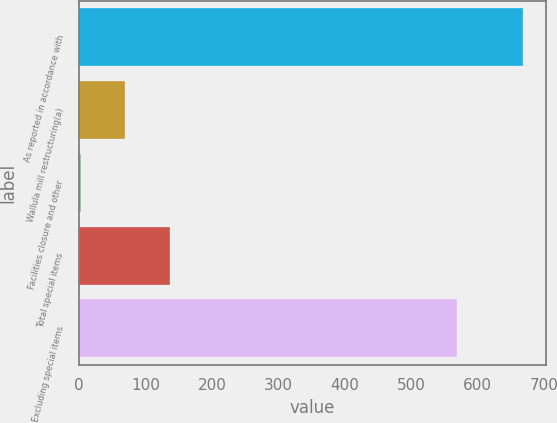Convert chart. <chart><loc_0><loc_0><loc_500><loc_500><bar_chart><fcel>As reported in accordance with<fcel>Wallula mill restructuring(a)<fcel>Facilities closure and other<fcel>Total special items<fcel>Excluding special items<nl><fcel>668.6<fcel>70.01<fcel>3.5<fcel>136.52<fcel>569.1<nl></chart> 